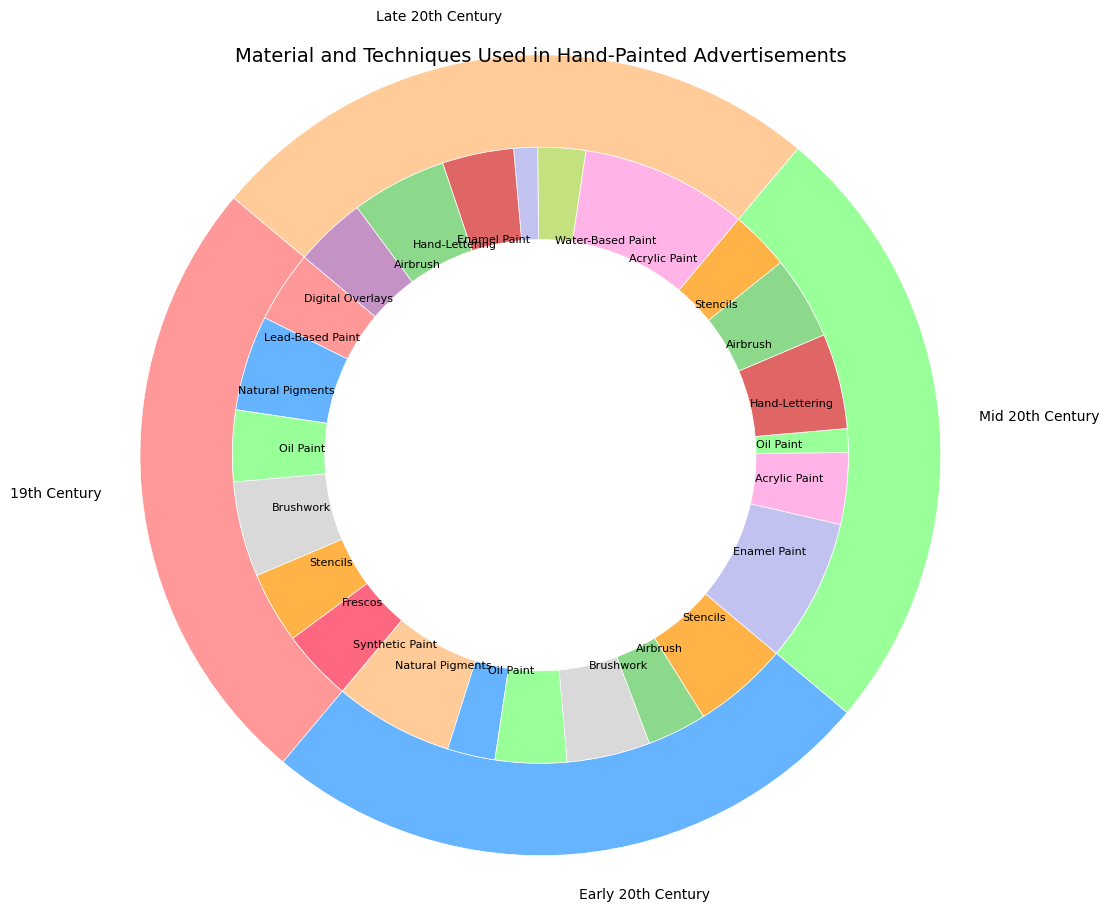Which historical period used brushwork the most? Brushwork appears in the 19th Century (40%), Early 20th Century (35%), and is absent in Mid and Late 20th Century. Comparing these percentages, the 19th Century used brushwork the most at 40%.
Answer: 19th Century Which material was most popular in the Mid 20th Century? In the Mid 20th Century, the materials used were Enamel Paint (60%), Acrylic Paint (30%), and Oil Paint (10%). Enamel Paint has the highest percentage at 60%.
Answer: Enamel Paint Compare the usage of Lead-Based Paint and Digital Overlays across all periods. Which was more commonly used? Lead-Based Paint was only used in the 19th Century (30%). Digital Overlays were used in the Late 20th Century (30%). Both Lead-Based Paint and Digital Overlays were used at 30%, making their usage equal.
Answer: Equal Calculate the total percentage of Oil Paint usage across all periods. Oil Paint is used in the 19th Century (30%), Early 20th Century (30%), and Mid 20th Century (10%). Summing these percentages, we get 30% + 30% + 10% = 70%.
Answer: 70% Which technique was only used in the Late 20th Century? In the Late 20th Century, the unique technique present is Digital Overlays (30%). It does not appear in earlier periods.
Answer: Digital Overlays What period saw the highest usage of Synthetic Paint? Synthetic Paint is only mentioned in the Early 20th Century (50%). Therefore, the Early 20th Century saw the highest usage, which is 50%.
Answer: Early 20th Century 